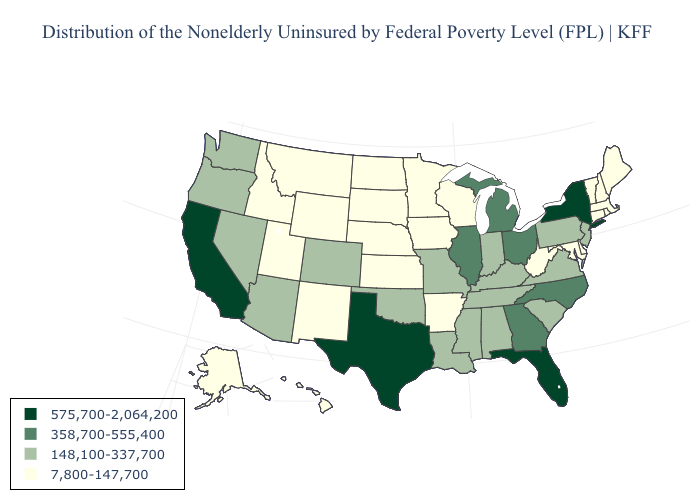Name the states that have a value in the range 148,100-337,700?
Give a very brief answer. Alabama, Arizona, Colorado, Indiana, Kentucky, Louisiana, Mississippi, Missouri, Nevada, New Jersey, Oklahoma, Oregon, Pennsylvania, South Carolina, Tennessee, Virginia, Washington. Does the first symbol in the legend represent the smallest category?
Give a very brief answer. No. Name the states that have a value in the range 358,700-555,400?
Write a very short answer. Georgia, Illinois, Michigan, North Carolina, Ohio. Does the map have missing data?
Write a very short answer. No. What is the lowest value in the USA?
Write a very short answer. 7,800-147,700. What is the value of Missouri?
Keep it brief. 148,100-337,700. Does the map have missing data?
Answer briefly. No. What is the value of Montana?
Short answer required. 7,800-147,700. What is the highest value in the Northeast ?
Keep it brief. 575,700-2,064,200. Name the states that have a value in the range 148,100-337,700?
Keep it brief. Alabama, Arizona, Colorado, Indiana, Kentucky, Louisiana, Mississippi, Missouri, Nevada, New Jersey, Oklahoma, Oregon, Pennsylvania, South Carolina, Tennessee, Virginia, Washington. What is the value of Ohio?
Short answer required. 358,700-555,400. Name the states that have a value in the range 148,100-337,700?
Answer briefly. Alabama, Arizona, Colorado, Indiana, Kentucky, Louisiana, Mississippi, Missouri, Nevada, New Jersey, Oklahoma, Oregon, Pennsylvania, South Carolina, Tennessee, Virginia, Washington. Name the states that have a value in the range 358,700-555,400?
Quick response, please. Georgia, Illinois, Michigan, North Carolina, Ohio. What is the lowest value in the West?
Give a very brief answer. 7,800-147,700. Which states have the lowest value in the West?
Answer briefly. Alaska, Hawaii, Idaho, Montana, New Mexico, Utah, Wyoming. 